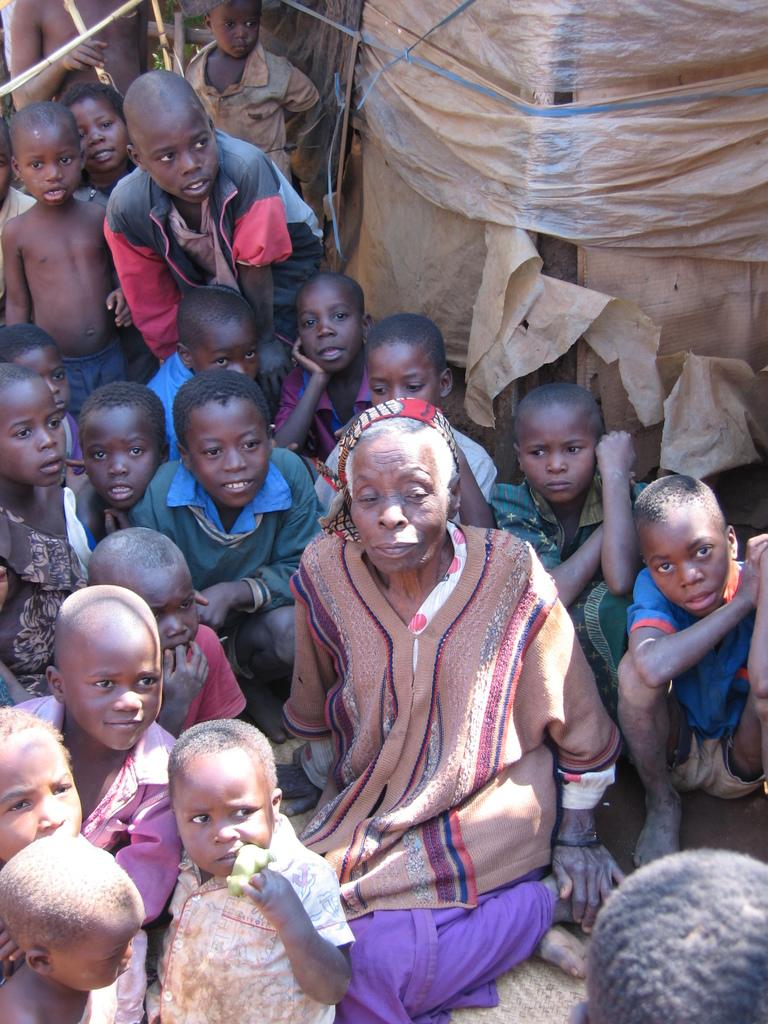How many people are in the image? There is a group of people in the image, but the exact number is not specified. What are the people doing in the image? The people are sitting on a path in the image. What is the purpose of the plastic cover visible in the image? The purpose of the plastic cover is not specified in the given facts. What can be seen behind the people in the image? There are other unspecified things behind the people in the image. How many boys are standing on the bridge in the image? There is no bridge or boys present in the image. What type of slip is visible on the path in the image? There is no slip visible on the path in the image. 